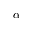Convert formula to latex. <formula><loc_0><loc_0><loc_500><loc_500>\alpha</formula> 